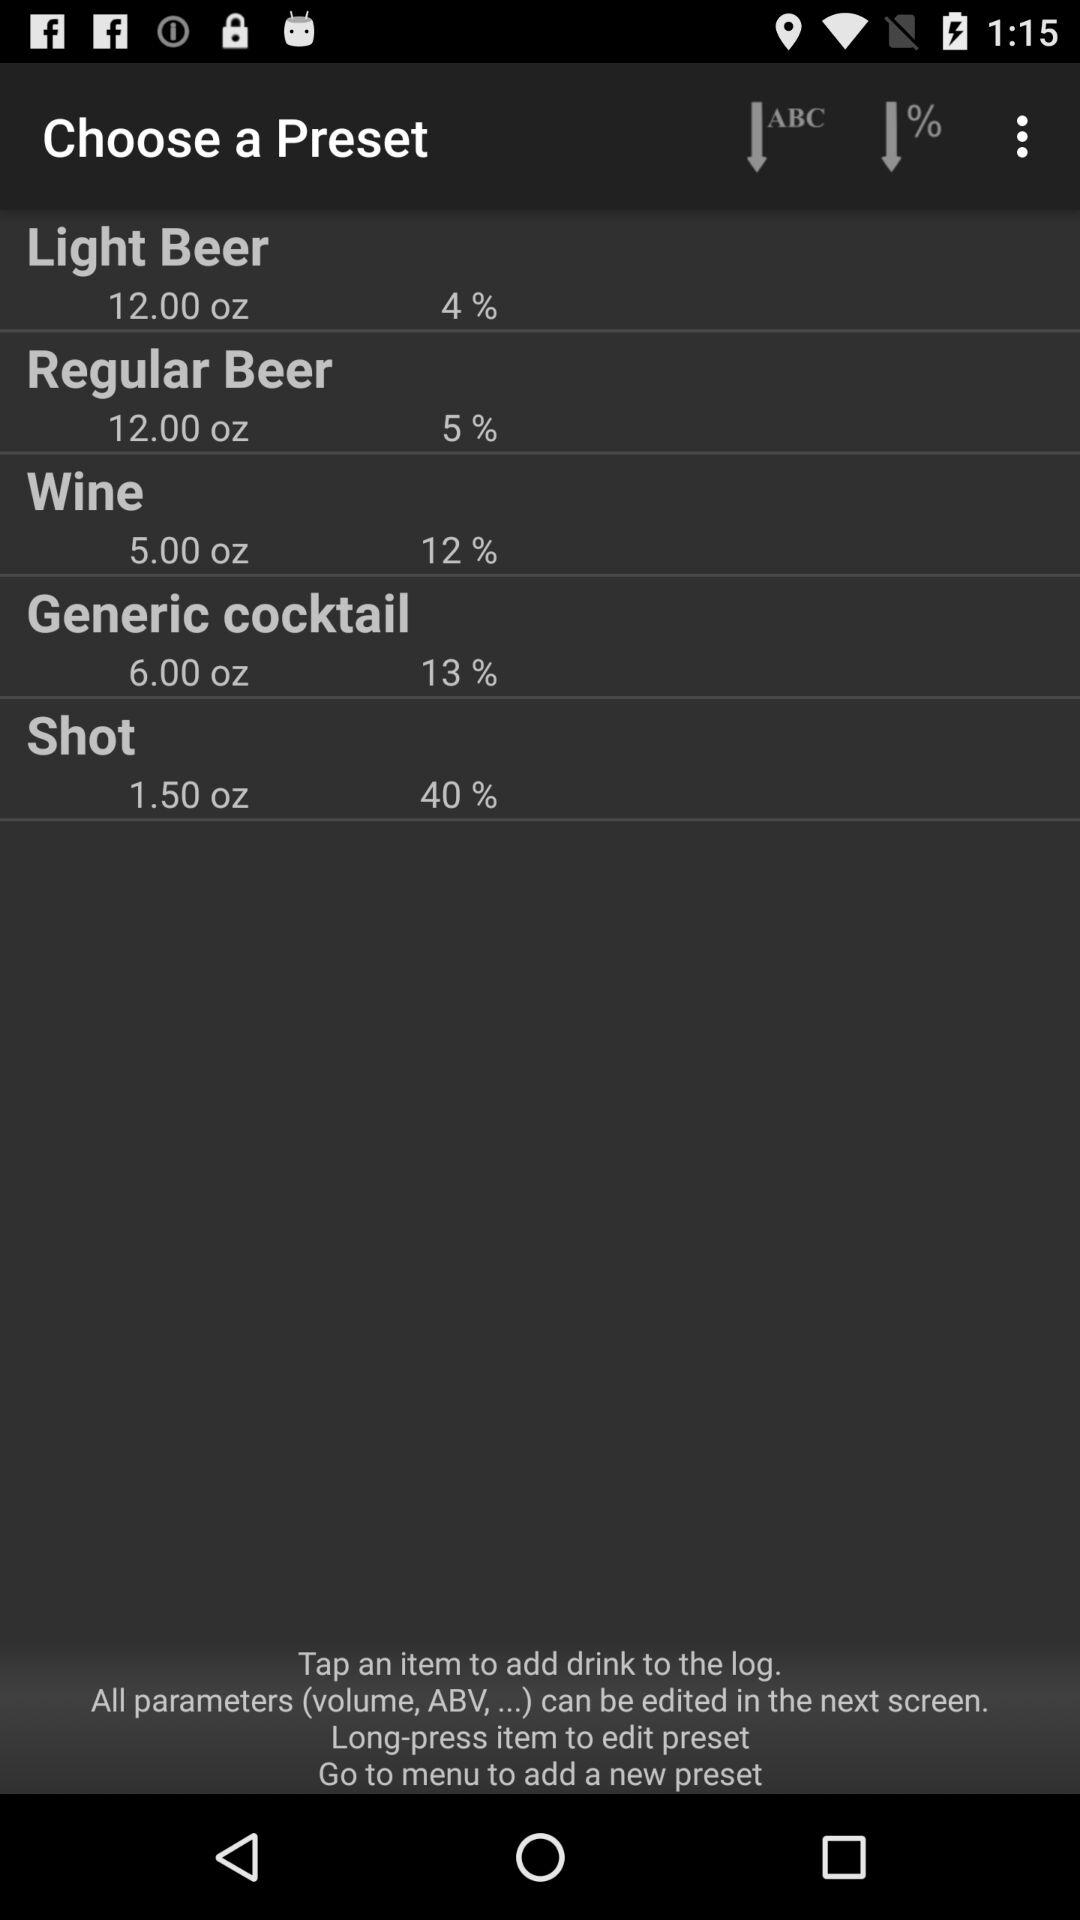What is the percentage for "Shot"? The percentage is 40%. 